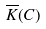Convert formula to latex. <formula><loc_0><loc_0><loc_500><loc_500>\overline { K } ( C )</formula> 